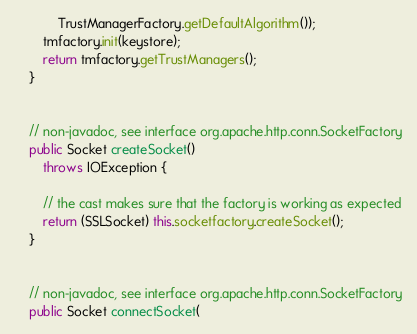Convert code to text. <code><loc_0><loc_0><loc_500><loc_500><_Java_>            TrustManagerFactory.getDefaultAlgorithm());
        tmfactory.init(keystore);
        return tmfactory.getTrustManagers();
    }


    // non-javadoc, see interface org.apache.http.conn.SocketFactory
    public Socket createSocket()
        throws IOException {

        // the cast makes sure that the factory is working as expected
        return (SSLSocket) this.socketfactory.createSocket();
    }


    // non-javadoc, see interface org.apache.http.conn.SocketFactory
    public Socket connectSocket(</code> 